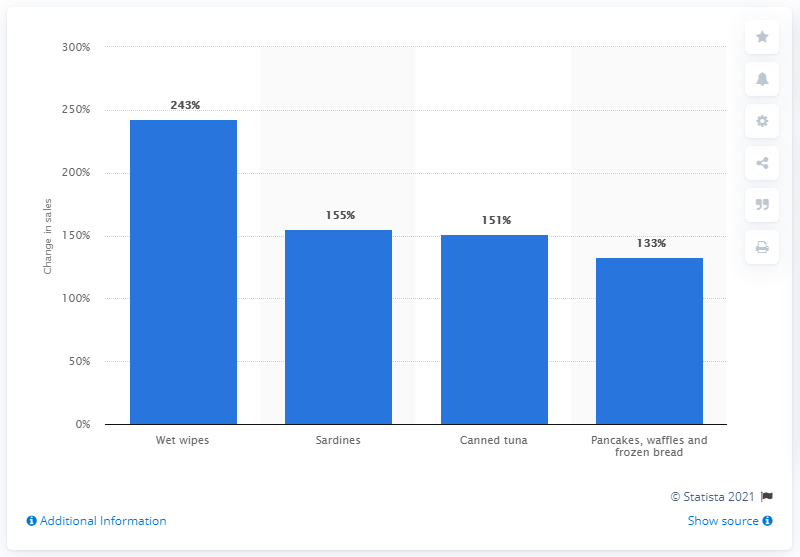Draw attention to some important aspects in this diagram. The sales of wet wipes increased by 243%. The sales of sardines and canned tuna increased by 151% in the given period. 